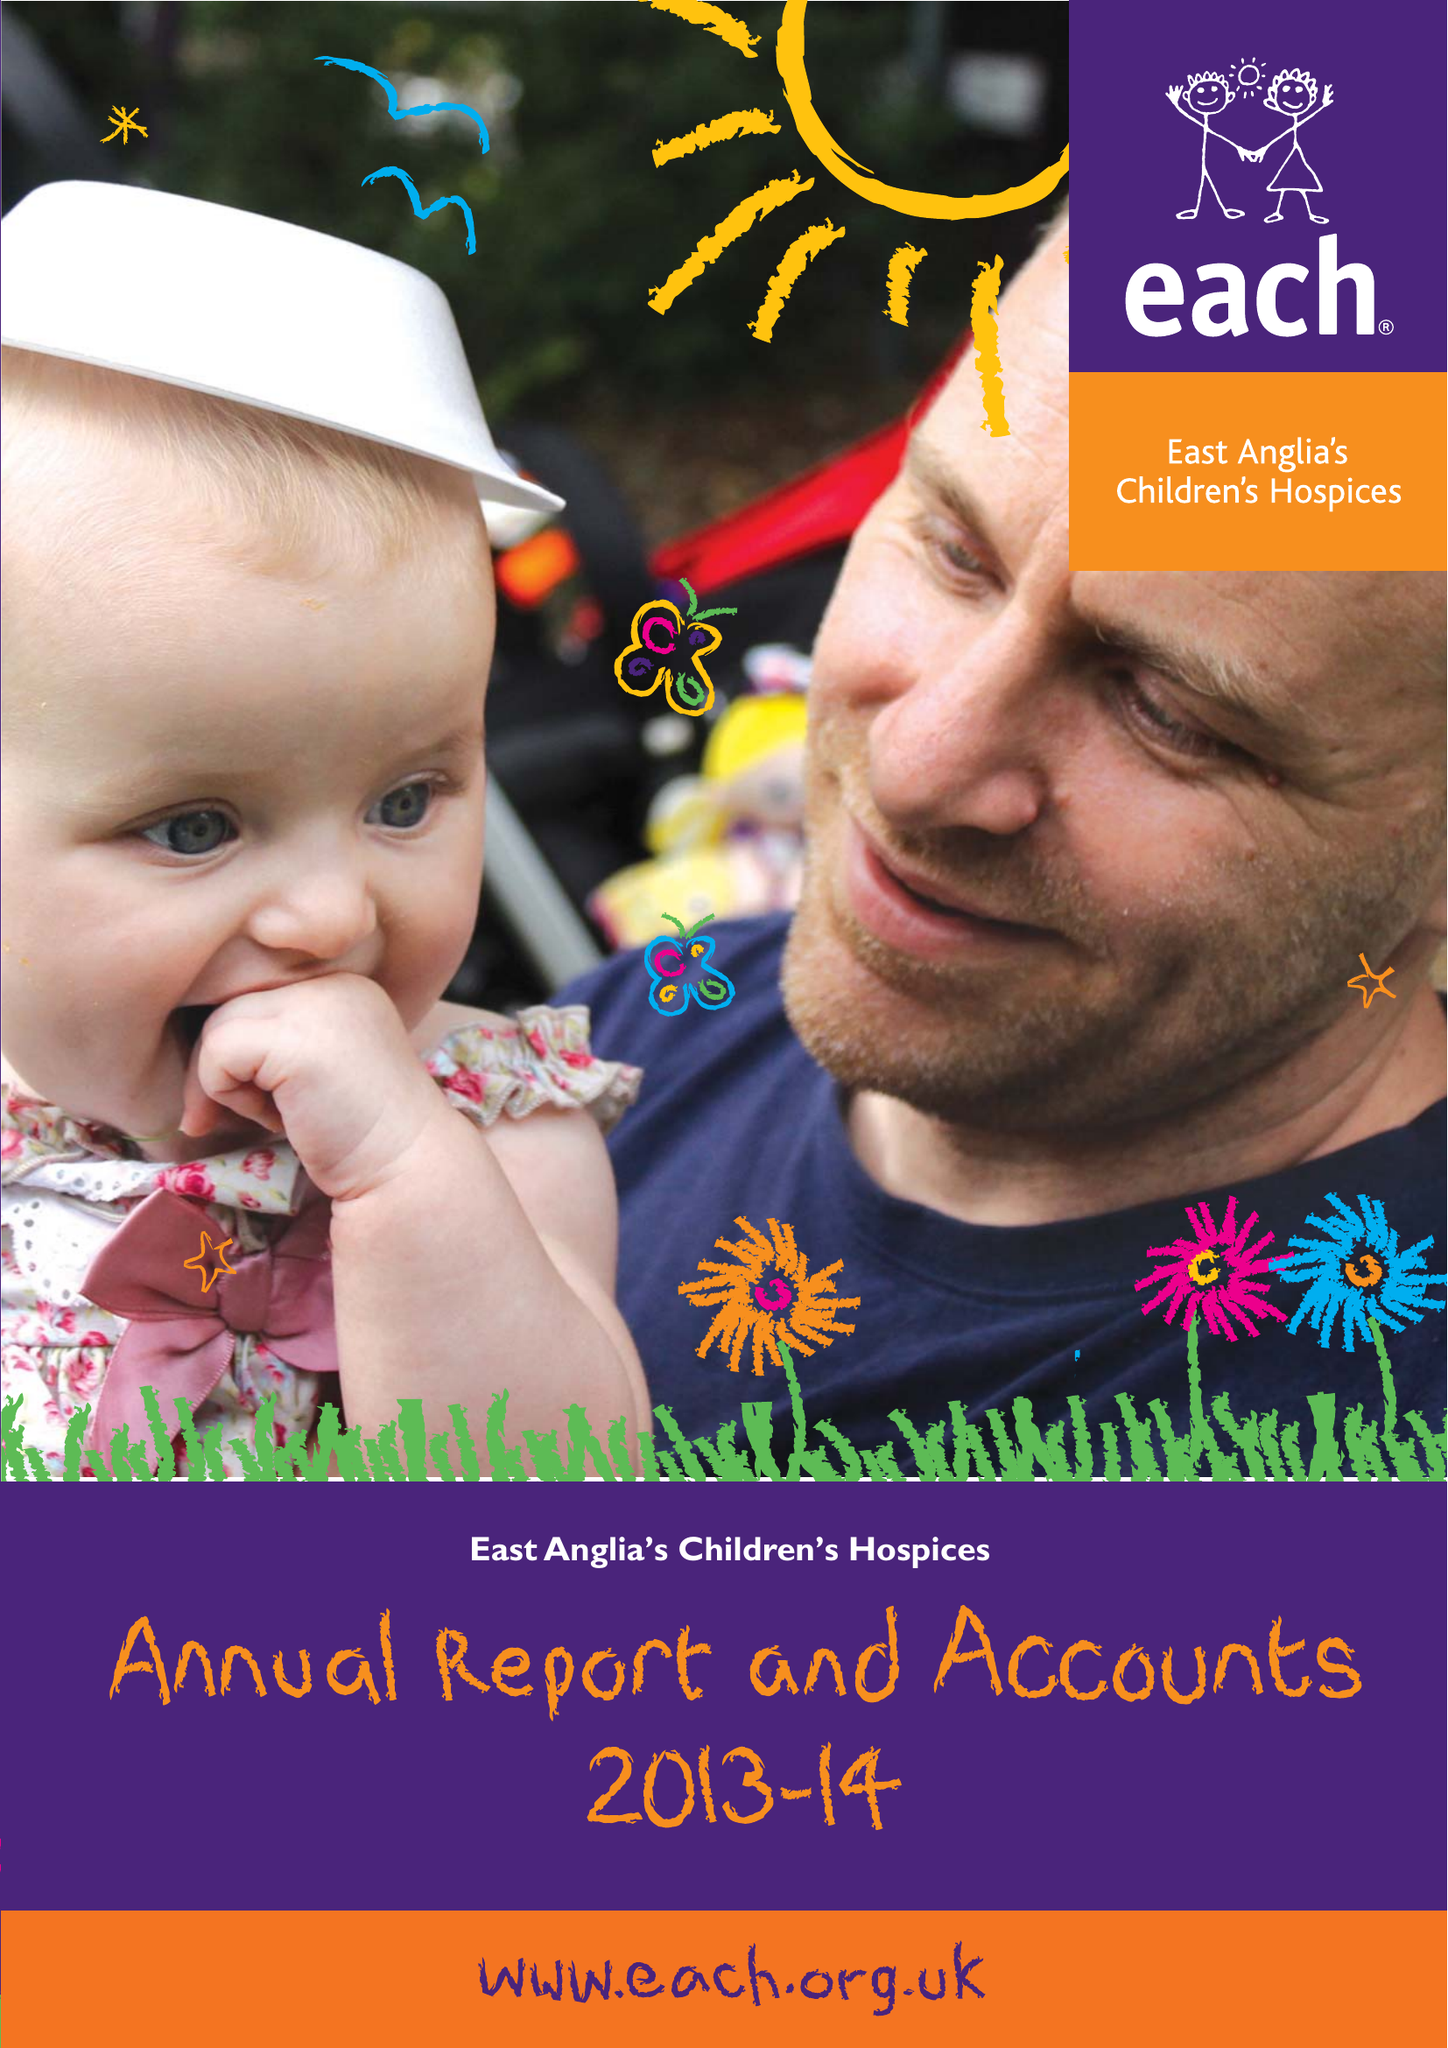What is the value for the charity_number?
Answer the question using a single word or phrase. 1069284 